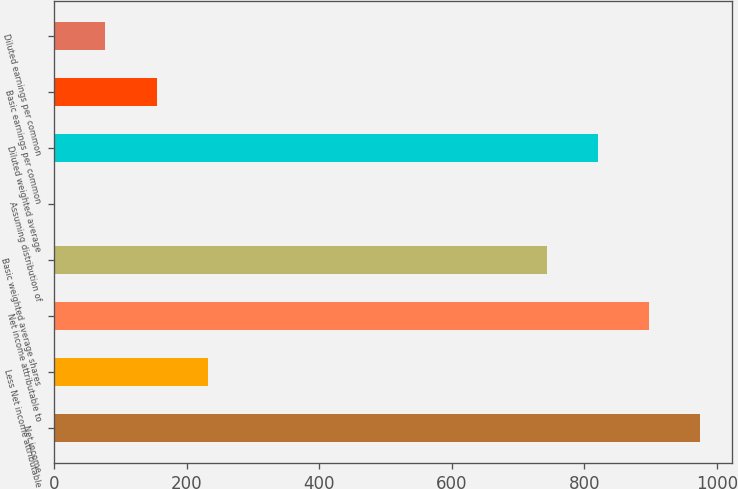<chart> <loc_0><loc_0><loc_500><loc_500><bar_chart><fcel>Net income<fcel>Less Net income attributable<fcel>Net income attributable to<fcel>Basic weighted average shares<fcel>Assuming distribution of<fcel>Diluted weighted average<fcel>Basic earnings per common<fcel>Diluted earnings per common<nl><fcel>974.09<fcel>231.79<fcel>897.06<fcel>743<fcel>0.7<fcel>820.03<fcel>154.76<fcel>77.73<nl></chart> 